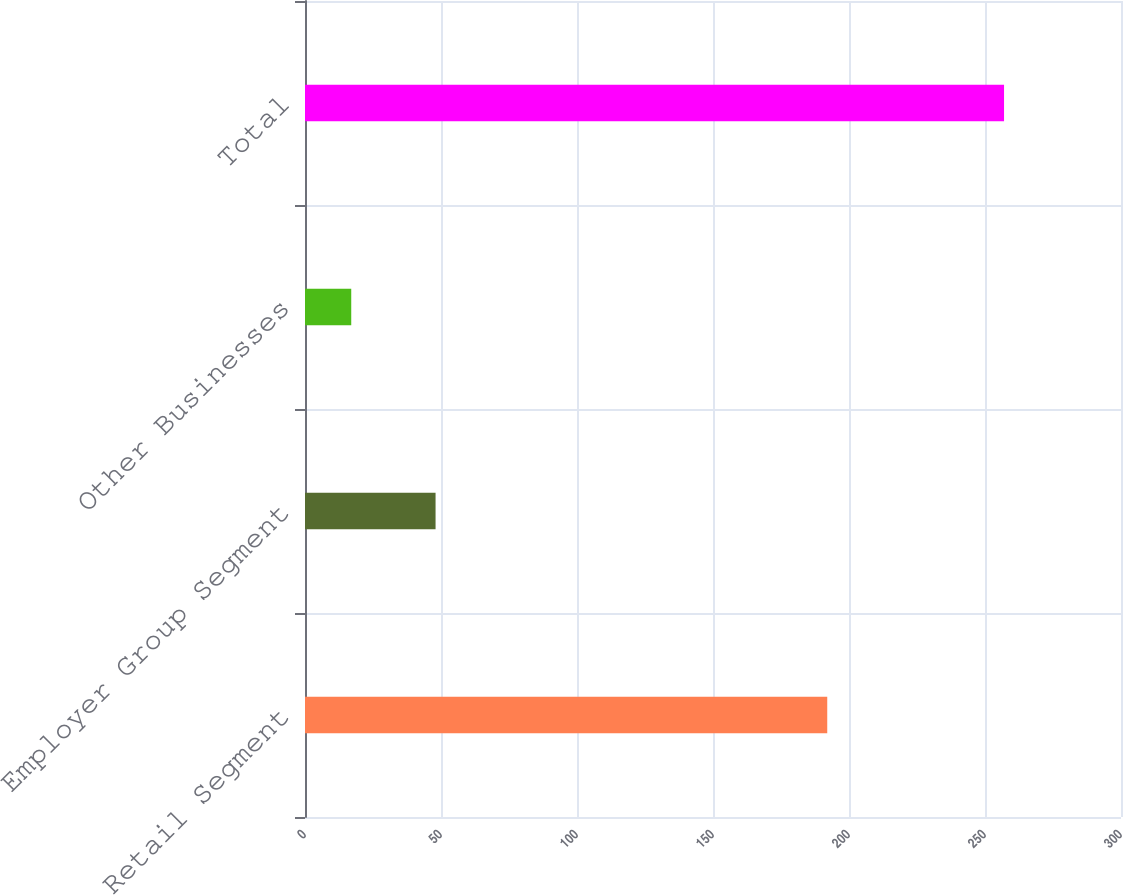<chart> <loc_0><loc_0><loc_500><loc_500><bar_chart><fcel>Retail Segment<fcel>Employer Group Segment<fcel>Other Businesses<fcel>Total<nl><fcel>192<fcel>48<fcel>17<fcel>257<nl></chart> 